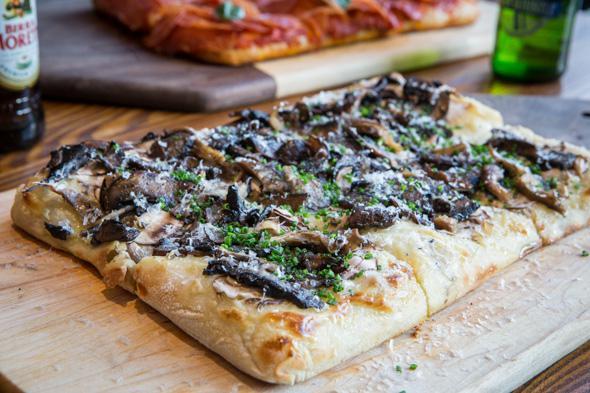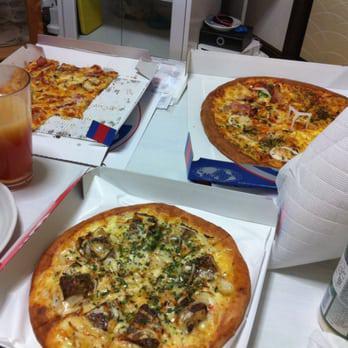The first image is the image on the left, the second image is the image on the right. Given the left and right images, does the statement "The left and right image contains the same number of circle shaped pizzas." hold true? Answer yes or no. No. The first image is the image on the left, the second image is the image on the right. For the images shown, is this caption "Each image contains exactly one rounded pizza with no slices missing." true? Answer yes or no. No. 